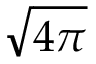Convert formula to latex. <formula><loc_0><loc_0><loc_500><loc_500>\sqrt { 4 \pi }</formula> 